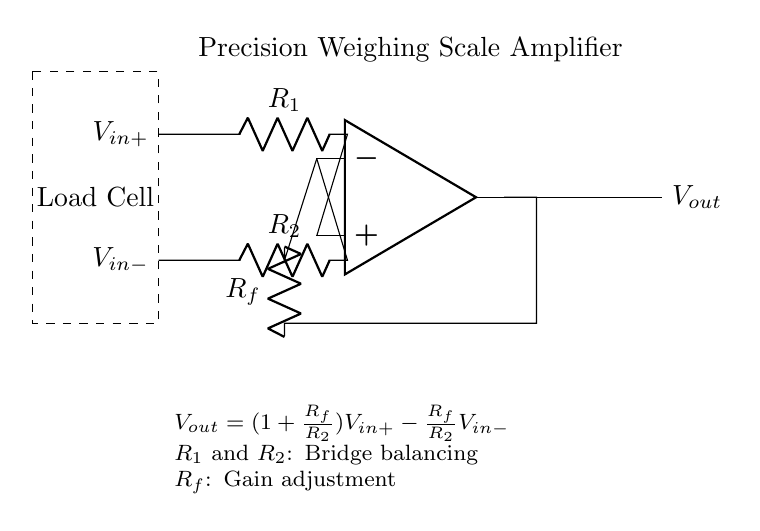What type of amplifier is used here? This circuit utilizes an operational amplifier, which is a type of amplifier characterized by high input impedance and low output impedance, making it ideal for applications such as precision weighing scales.
Answer: operational amplifier What determines the gain of this amplifier? The gain of the operational amplifier in this circuit is determined by the resistors R_f and R_2 as per the formula given: V_out = (1 + R_f/R_2)V_in+ - (R_f/R_2)V_in-. The configuration allows for gain adjustment based on R_f and R_2 values.
Answer: R_f and R_2 What is the purpose of R_1 and R_2 in this circuit? R_1 and R_2 are used for bridge balancing in the circuit, which helps to ensure that the voltage levels at V_in+ and V_in- are appropriately controlled to provide accurate output from the amplifier.
Answer: bridge balancing What is the output voltage expression for this configuration? The output voltage expression for the operational amplifier circuit can be derived from the configuration, which indicates that V_out is given by the equation: V_out = (1 + R_f/R_2)V_in+ - (R_f/R_2)V_in-. This shows how the output voltage is influenced by the input voltages and resistor values.
Answer: V_out = (1 + R_f/R_2)V_in+ - (R_f/R_2)V_in- What is the role of the load cell in the circuit? The load cell serves as the input sensor that converts mechanical force (weight of produce) into an electrical signal, which is then amplified by the operational amplifier. It is essential for accurate measurement in weighing scales.
Answer: input sensor What happens if R_f is increased? Increasing R_f will increase the gain of the amplifier, which corresponds to a higher amplification of the input signal. As gain increases, the output voltage, V_out, will also increase for the same input voltage. This can lead to saturation or distortion if not managed properly.
Answer: gain increases How are the nodes connected in this circuit? The circuit connects the positive input (V_in+) to resistor R_1, the negative input (V_in-) to resistor R_2, and employs feedback through R_f. The connections create a non-inverting amplifier configuration, ensuring proper function of the precision weighing scale.
Answer: non-inverting configuration 